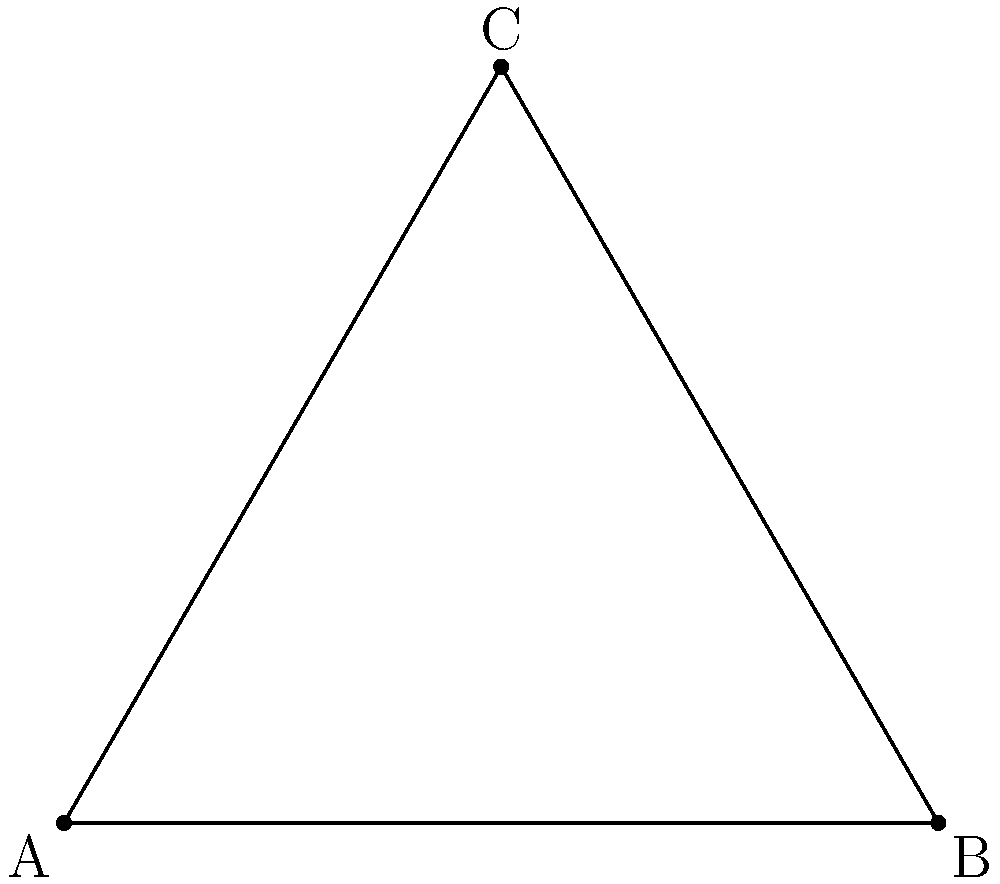In a peacekeeping operation, observation posts are being set up in the shape of an equilateral triangle with side length 4 units. Each post has a circular surveillance range with radius $r$. What is the minimum value of $r$ needed to ensure complete coverage of the triangular area? To solve this problem, we'll follow these steps:

1) In an equilateral triangle, the center of the triangle is equidistant from all three vertices and sides.

2) The distance from the center to a vertex is $\frac{2}{3}$ of the height of the triangle.

3) The height (h) of an equilateral triangle with side length $a$ is given by:
   $$h = \frac{\sqrt{3}}{2}a$$

4) In this case, $a = 4$, so the height is:
   $$h = \frac{\sqrt{3}}{2} \cdot 4 = 2\sqrt{3}$$

5) The distance from the center to a vertex (d) is:
   $$d = \frac{2}{3} \cdot 2\sqrt{3} = \frac{4\sqrt{3}}{3}$$

6) For complete coverage, the radius $r$ must be at least this distance.

Therefore, the minimum value of $r$ is $\frac{4\sqrt{3}}{3}$.
Answer: $\frac{4\sqrt{3}}{3}$ units 